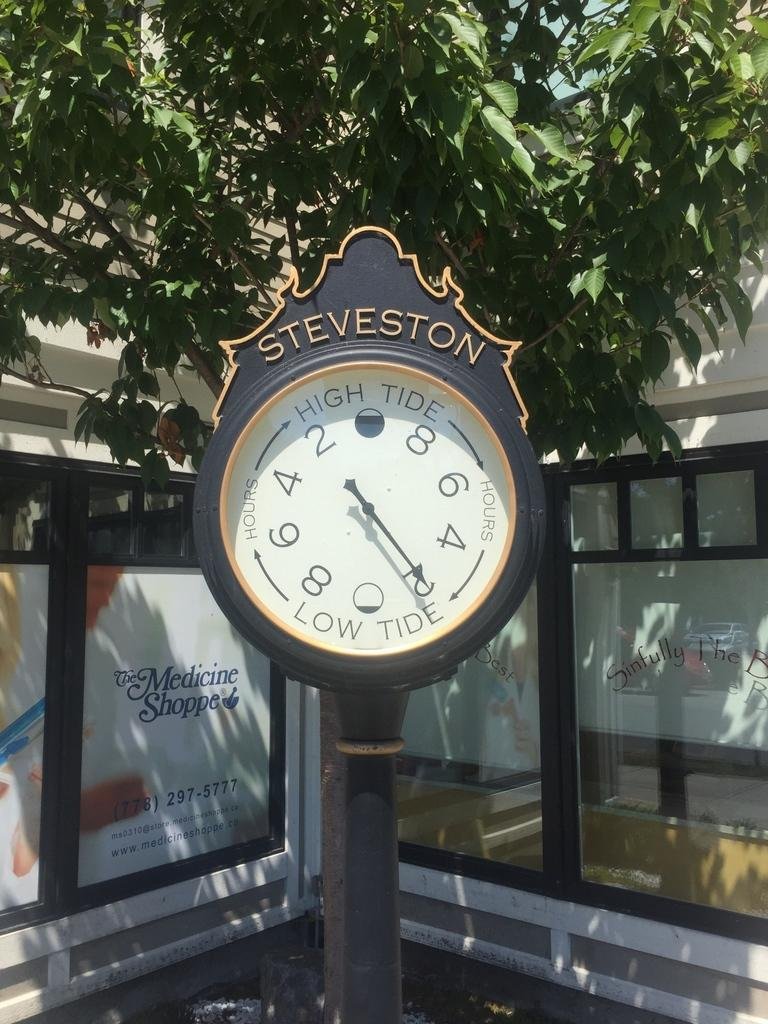<image>
Provide a brief description of the given image. A clock of sorts that shows how many hours til high tide and low tide. 